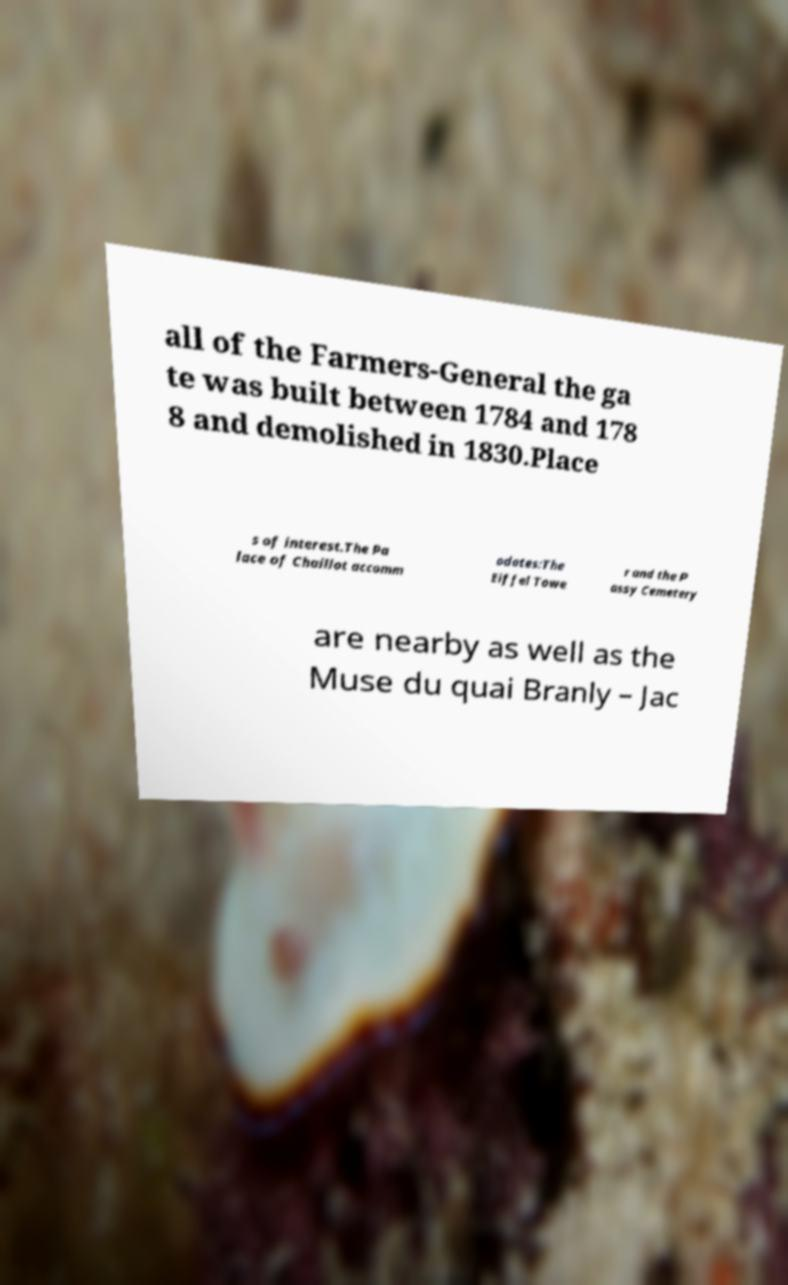Could you assist in decoding the text presented in this image and type it out clearly? all of the Farmers-General the ga te was built between 1784 and 178 8 and demolished in 1830.Place s of interest.The Pa lace of Chaillot accomm odates:The Eiffel Towe r and the P assy Cemetery are nearby as well as the Muse du quai Branly – Jac 